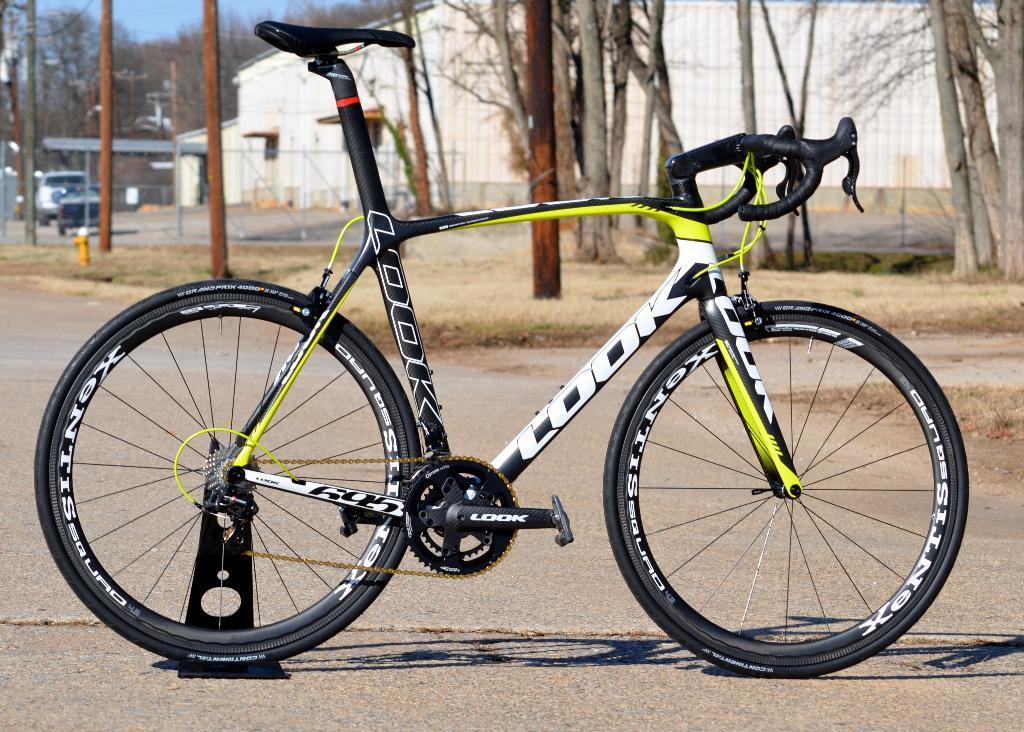In one or two sentences, can you explain what this image depicts? In the picture we can see a bicycle, which is black in color which is placed on the road and behind it, we can see a grass surface and some poles and trees on it and behind it, we can see some building wall with windows and trees, vehicles on the road and sky. 